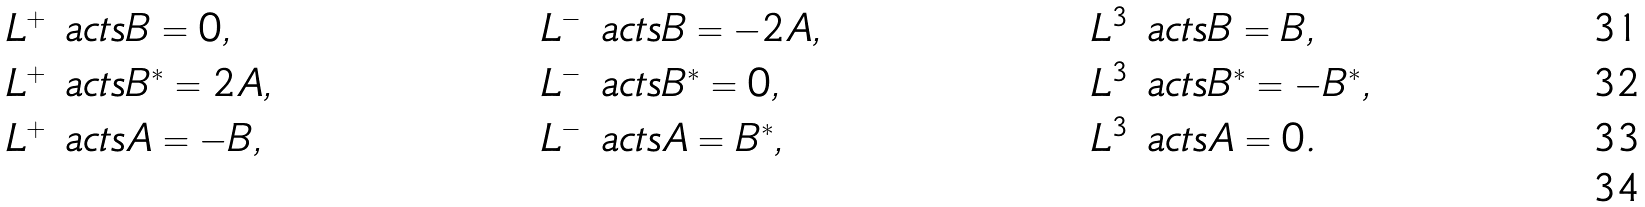Convert formula to latex. <formula><loc_0><loc_0><loc_500><loc_500>& L ^ { + } \ a c t s B = 0 , & & L ^ { - } \ a c t s B = - 2 A , & & L ^ { 3 } \ a c t s B = B , \\ & L ^ { + } \ a c t s B ^ { * } = 2 A , & & L ^ { - } \ a c t s B ^ { * } = 0 , & & L ^ { 3 } \ a c t s B ^ { * } = - B ^ { * } , \\ & L ^ { + } \ a c t s A = - B , & & L ^ { - } \ a c t s A = B ^ { * } , & & L ^ { 3 } \ a c t s A = 0 . \\</formula> 